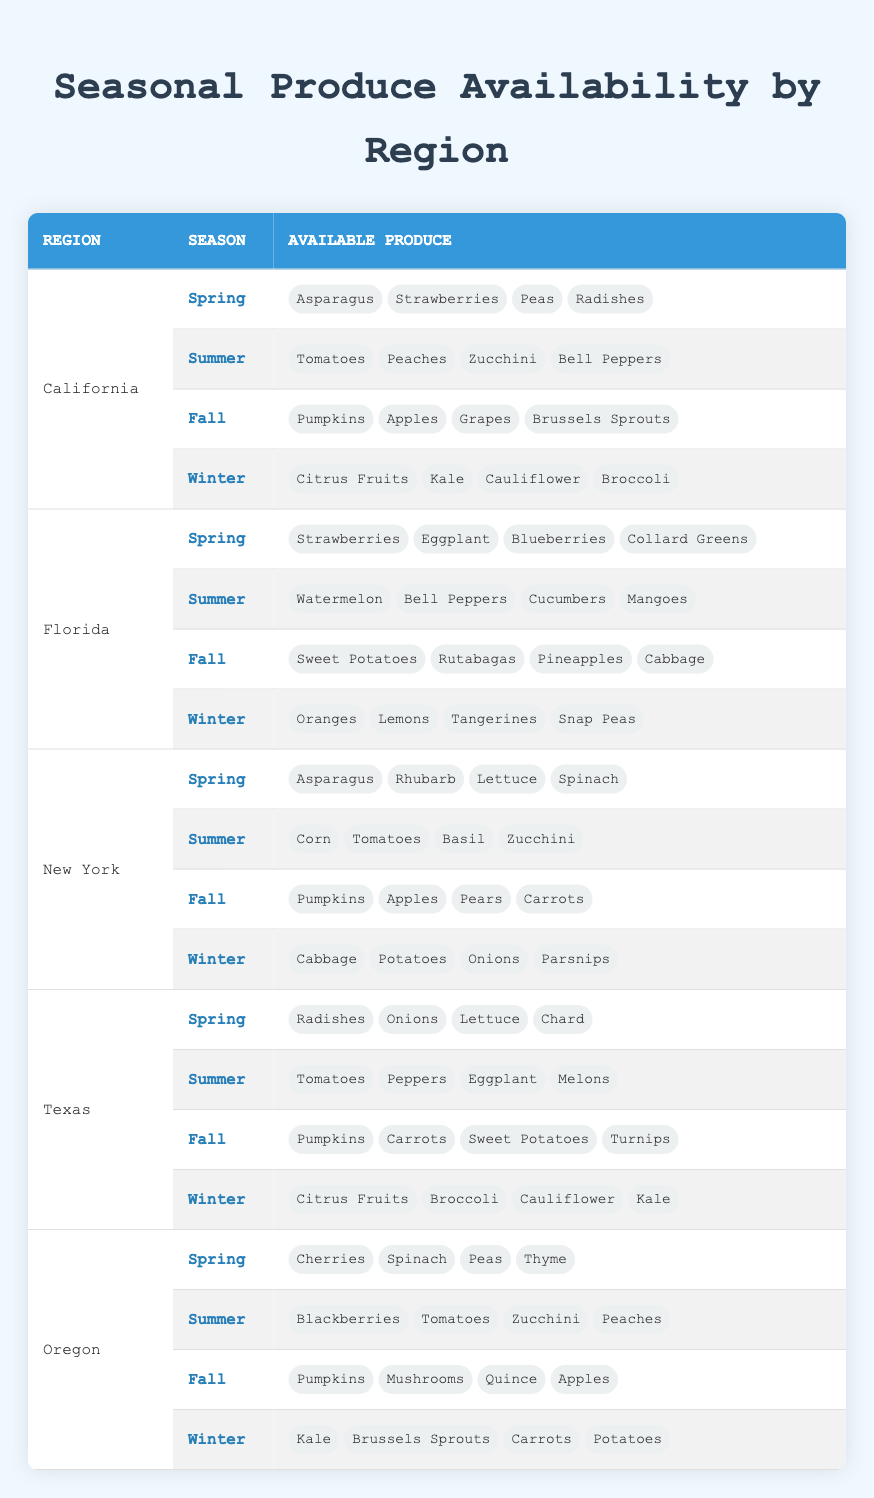What produce is available in California during Fall? From the table, look for the row that specifies California in the Fall season. The list mentions Pumpkins, Apples, Grapes, and Brussels Sprouts as the produce available during that season.
Answer: Pumpkins, Apples, Grapes, Brussels Sprouts Is there any produce available in Florida during Winter? Check the Winter row for Florida in the table. The produce listed for that season includes Oranges, Lemons, Tangerines, and Snap Peas, confirming availability.
Answer: Yes Which region offers the highest diversity of produce in Spring? To determine diversity in Spring, list the regions provided in the table. Calculate the count of distinct produce for each Spring season entry: California has 4, Florida has 4, New York has 4, Texas has 4, and Oregon has 4. All have the same count, so the diversity is equal across these regions.
Answer: All regions have equal diversity How many different types of produce can be found in New York throughout the summer and fall combined? First, identify the produce listed for New York during Summer (Corn, Tomatoes, Basil, Zucchini) and Fall (Pumpkins, Apples, Pears, Carrots). Count them together: 4 (Summer) + 4 (Fall) = 8 unique types of produce. Thus, the total is confirmed by their uniqueness.
Answer: 8 Are there any vegetables available in Texas during Winter? Investigate the Texas section in the Winter row. The produce includes Citrus Fruits, Broccoli, Cauliflower, and Kale. All are considered vegetables, confirming vegetable availability in that region during Winter.
Answer: Yes Which season has the most distinct types of produce available in Oregon? To find the season with the most distinct types, sum the unique produce offerings for each season in Oregon: Spring has 4, Summer has 4, Fall has 4, Winter has 4. All seasons in Oregon have an equal amount of distinct produce, leading to uniformity across seasons.
Answer: All seasons are equal What is the total number of types of produce available in Florida? Gather all the produce listed for Florida in each season: Spring (4), Summer (4), Fall (4), Winter (4). When added together, you find 4 + 4 + 4 + 4 = 16, giving the total of different produce available across the seasons.
Answer: 16 Do you find any seafood listed in the produce data? Review the entire table for mentions of seafood. As examined, the entries only reference fruits and vegetables; no seafood is present. Therefore, it confirms that there is no seafood in the data.
Answer: No 